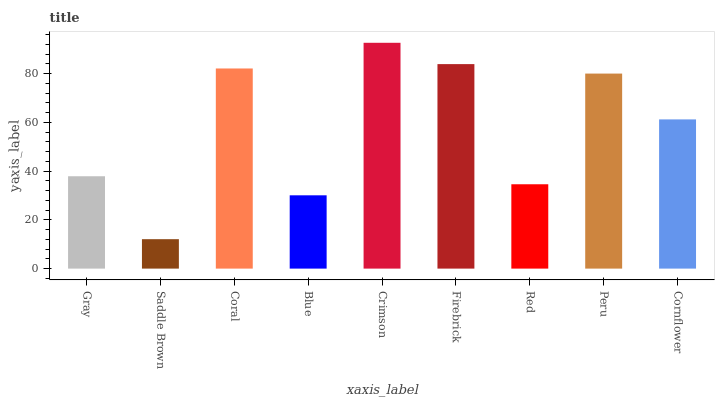Is Saddle Brown the minimum?
Answer yes or no. Yes. Is Crimson the maximum?
Answer yes or no. Yes. Is Coral the minimum?
Answer yes or no. No. Is Coral the maximum?
Answer yes or no. No. Is Coral greater than Saddle Brown?
Answer yes or no. Yes. Is Saddle Brown less than Coral?
Answer yes or no. Yes. Is Saddle Brown greater than Coral?
Answer yes or no. No. Is Coral less than Saddle Brown?
Answer yes or no. No. Is Cornflower the high median?
Answer yes or no. Yes. Is Cornflower the low median?
Answer yes or no. Yes. Is Red the high median?
Answer yes or no. No. Is Blue the low median?
Answer yes or no. No. 